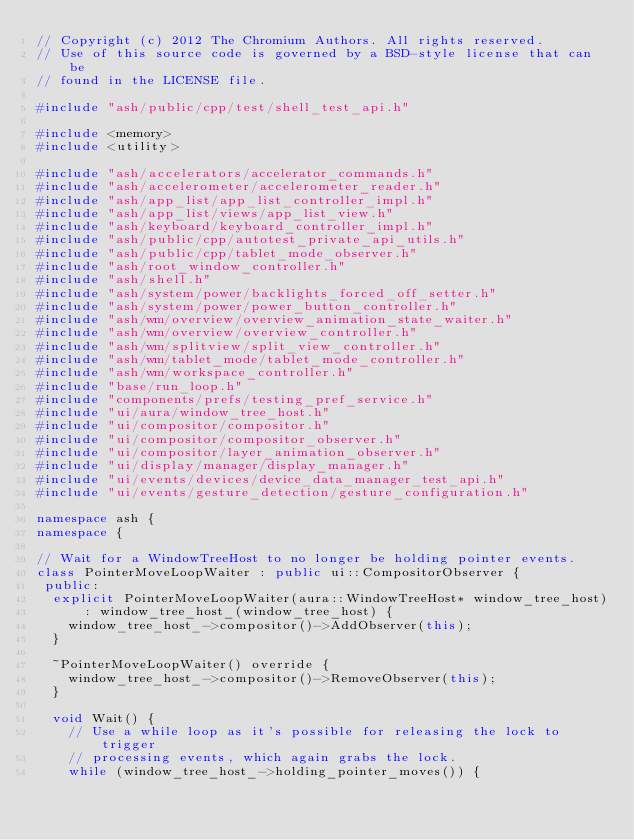Convert code to text. <code><loc_0><loc_0><loc_500><loc_500><_C++_>// Copyright (c) 2012 The Chromium Authors. All rights reserved.
// Use of this source code is governed by a BSD-style license that can be
// found in the LICENSE file.

#include "ash/public/cpp/test/shell_test_api.h"

#include <memory>
#include <utility>

#include "ash/accelerators/accelerator_commands.h"
#include "ash/accelerometer/accelerometer_reader.h"
#include "ash/app_list/app_list_controller_impl.h"
#include "ash/app_list/views/app_list_view.h"
#include "ash/keyboard/keyboard_controller_impl.h"
#include "ash/public/cpp/autotest_private_api_utils.h"
#include "ash/public/cpp/tablet_mode_observer.h"
#include "ash/root_window_controller.h"
#include "ash/shell.h"
#include "ash/system/power/backlights_forced_off_setter.h"
#include "ash/system/power/power_button_controller.h"
#include "ash/wm/overview/overview_animation_state_waiter.h"
#include "ash/wm/overview/overview_controller.h"
#include "ash/wm/splitview/split_view_controller.h"
#include "ash/wm/tablet_mode/tablet_mode_controller.h"
#include "ash/wm/workspace_controller.h"
#include "base/run_loop.h"
#include "components/prefs/testing_pref_service.h"
#include "ui/aura/window_tree_host.h"
#include "ui/compositor/compositor.h"
#include "ui/compositor/compositor_observer.h"
#include "ui/compositor/layer_animation_observer.h"
#include "ui/display/manager/display_manager.h"
#include "ui/events/devices/device_data_manager_test_api.h"
#include "ui/events/gesture_detection/gesture_configuration.h"

namespace ash {
namespace {

// Wait for a WindowTreeHost to no longer be holding pointer events.
class PointerMoveLoopWaiter : public ui::CompositorObserver {
 public:
  explicit PointerMoveLoopWaiter(aura::WindowTreeHost* window_tree_host)
      : window_tree_host_(window_tree_host) {
    window_tree_host_->compositor()->AddObserver(this);
  }

  ~PointerMoveLoopWaiter() override {
    window_tree_host_->compositor()->RemoveObserver(this);
  }

  void Wait() {
    // Use a while loop as it's possible for releasing the lock to trigger
    // processing events, which again grabs the lock.
    while (window_tree_host_->holding_pointer_moves()) {</code> 